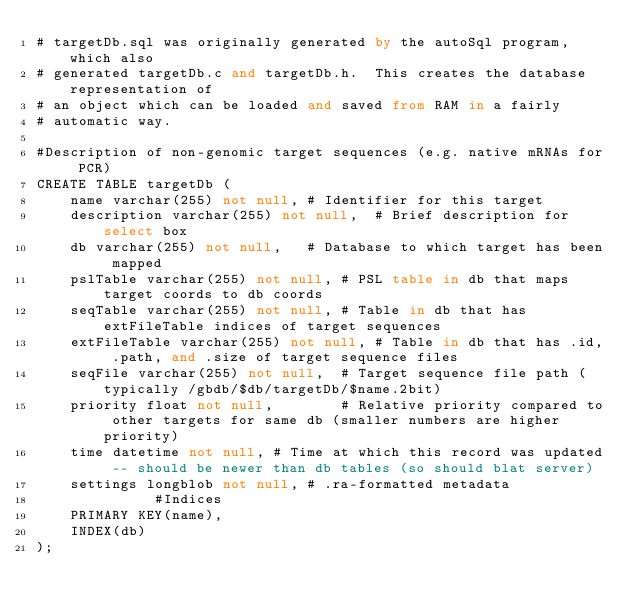<code> <loc_0><loc_0><loc_500><loc_500><_SQL_># targetDb.sql was originally generated by the autoSql program, which also 
# generated targetDb.c and targetDb.h.  This creates the database representation of
# an object which can be loaded and saved from RAM in a fairly 
# automatic way.

#Description of non-genomic target sequences (e.g. native mRNAs for PCR)
CREATE TABLE targetDb (
    name varchar(255) not null,	# Identifier for this target
    description varchar(255) not null,	# Brief description for select box
    db varchar(255) not null,	# Database to which target has been mapped
    pslTable varchar(255) not null,	# PSL table in db that maps target coords to db coords
    seqTable varchar(255) not null,	# Table in db that has extFileTable indices of target sequences
    extFileTable varchar(255) not null,	# Table in db that has .id, .path, and .size of target sequence files
    seqFile varchar(255) not null,	# Target sequence file path (typically /gbdb/$db/targetDb/$name.2bit)
    priority float not null,		# Relative priority compared to other targets for same db (smaller numbers are higher priority)
    time datetime not null,	# Time at which this record was updated -- should be newer than db tables (so should blat server)
    settings longblob not null,	# .ra-formatted metadata
              #Indices
    PRIMARY KEY(name),
    INDEX(db)
);
</code> 